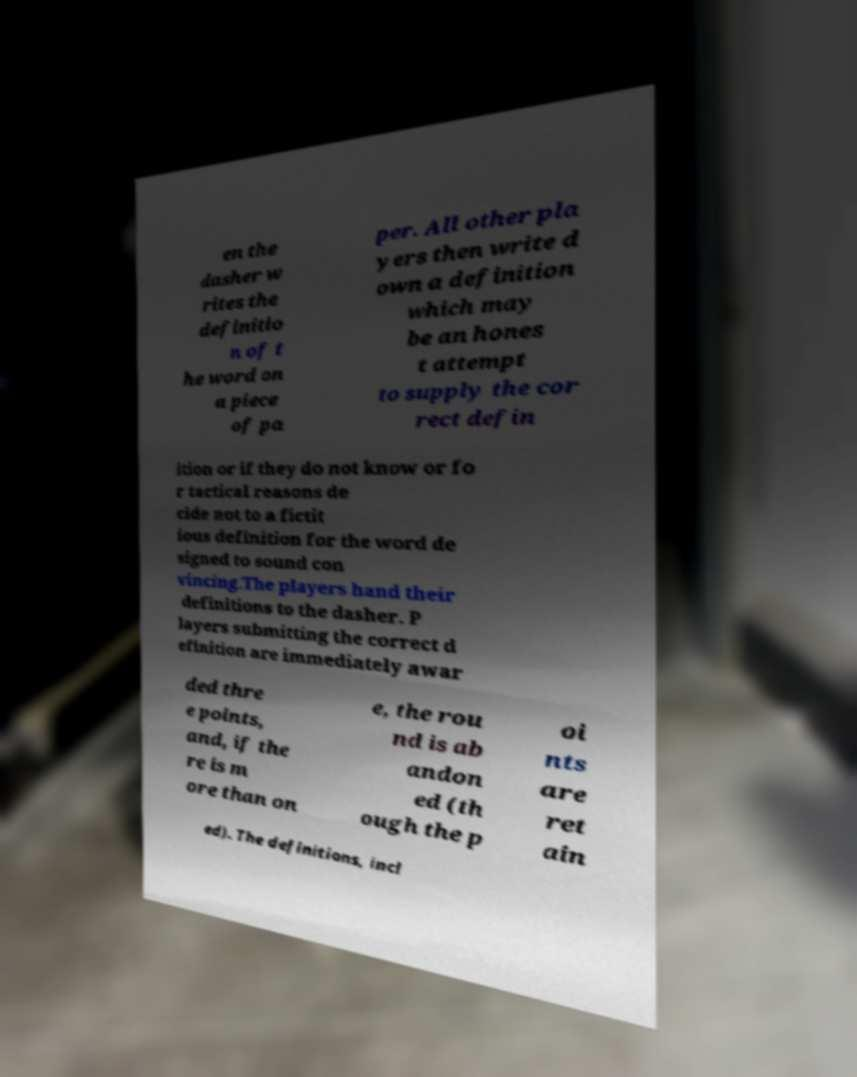Please read and relay the text visible in this image. What does it say? en the dasher w rites the definitio n of t he word on a piece of pa per. All other pla yers then write d own a definition which may be an hones t attempt to supply the cor rect defin ition or if they do not know or fo r tactical reasons de cide not to a fictit ious definition for the word de signed to sound con vincing.The players hand their definitions to the dasher. P layers submitting the correct d efinition are immediately awar ded thre e points, and, if the re is m ore than on e, the rou nd is ab andon ed (th ough the p oi nts are ret ain ed). The definitions, incl 